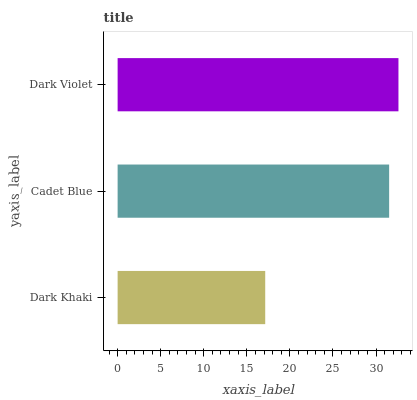Is Dark Khaki the minimum?
Answer yes or no. Yes. Is Dark Violet the maximum?
Answer yes or no. Yes. Is Cadet Blue the minimum?
Answer yes or no. No. Is Cadet Blue the maximum?
Answer yes or no. No. Is Cadet Blue greater than Dark Khaki?
Answer yes or no. Yes. Is Dark Khaki less than Cadet Blue?
Answer yes or no. Yes. Is Dark Khaki greater than Cadet Blue?
Answer yes or no. No. Is Cadet Blue less than Dark Khaki?
Answer yes or no. No. Is Cadet Blue the high median?
Answer yes or no. Yes. Is Cadet Blue the low median?
Answer yes or no. Yes. Is Dark Khaki the high median?
Answer yes or no. No. Is Dark Violet the low median?
Answer yes or no. No. 